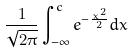<formula> <loc_0><loc_0><loc_500><loc_500>\frac { 1 } { \sqrt { 2 \pi } } \int _ { - \infty } ^ { c } e ^ { - \frac { x ^ { 2 } } { 2 } } d x</formula> 